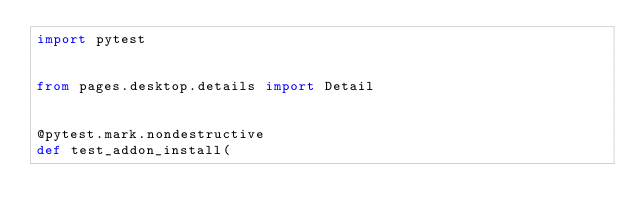Convert code to text. <code><loc_0><loc_0><loc_500><loc_500><_Python_>import pytest


from pages.desktop.details import Detail


@pytest.mark.nondestructive
def test_addon_install(</code> 